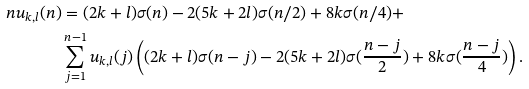<formula> <loc_0><loc_0><loc_500><loc_500>n u _ { k , l } ( n ) & = ( 2 k + l ) \sigma ( n ) - 2 ( 5 k + 2 l ) \sigma ( n / 2 ) + 8 k \sigma ( n / 4 ) + \\ & \sum _ { j = 1 } ^ { n - 1 } u _ { k , l } ( j ) \left ( ( 2 k + l ) \sigma ( n - j ) - 2 ( 5 k + 2 l ) \sigma ( \frac { n - j } { 2 } ) + 8 k \sigma ( \frac { n - j } { 4 } ) \right ) .</formula> 